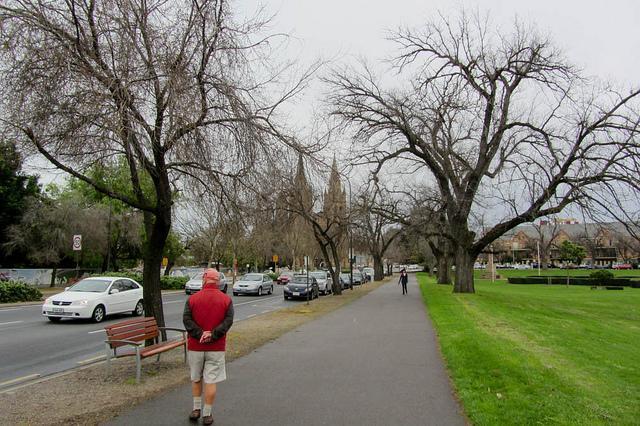What type trees are shown in the area nearest the red shirted walker?
From the following four choices, select the correct answer to address the question.
Options: Fern, palm, evergreen, deciduous. Deciduous. 